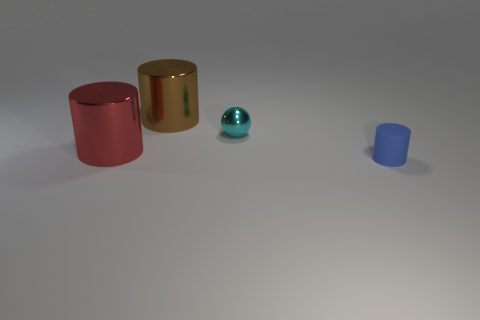Subtract 1 cylinders. How many cylinders are left? 2 Add 2 small yellow metallic balls. How many objects exist? 6 Subtract all cylinders. How many objects are left? 1 Subtract all small rubber cylinders. Subtract all blue cylinders. How many objects are left? 2 Add 2 shiny objects. How many shiny objects are left? 5 Add 4 red objects. How many red objects exist? 5 Subtract 1 cyan spheres. How many objects are left? 3 